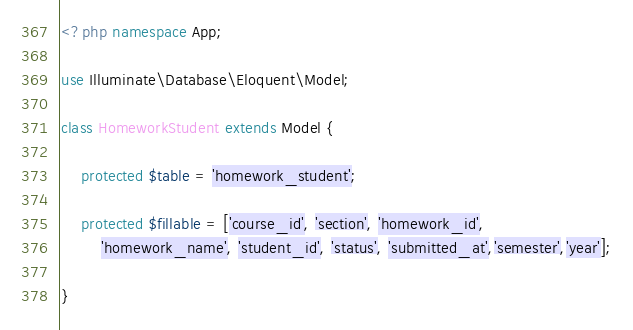Convert code to text. <code><loc_0><loc_0><loc_500><loc_500><_PHP_><?php namespace App;

use Illuminate\Database\Eloquent\Model;

class HomeworkStudent extends Model {

    protected $table = 'homework_student';

    protected $fillable = ['course_id', 'section', 'homework_id',
        'homework_name', 'student_id', 'status', 'submitted_at','semester','year'];

}
</code> 